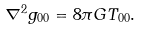Convert formula to latex. <formula><loc_0><loc_0><loc_500><loc_500>\nabla ^ { 2 } g _ { 0 0 } = 8 \pi G T _ { 0 0 } .</formula> 